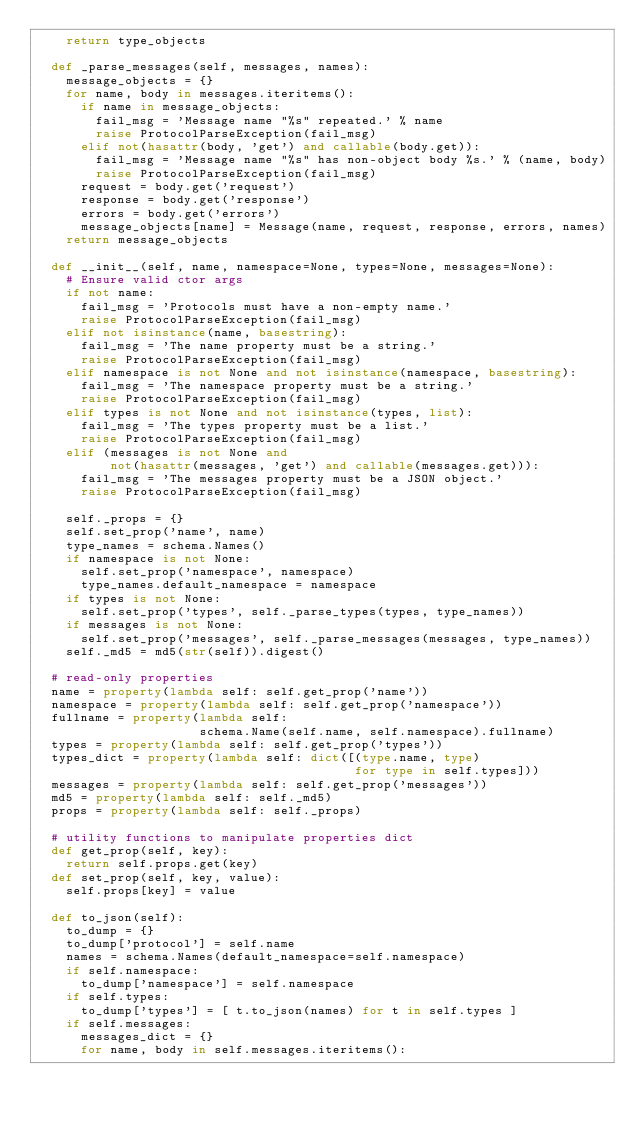Convert code to text. <code><loc_0><loc_0><loc_500><loc_500><_Python_>    return type_objects

  def _parse_messages(self, messages, names):
    message_objects = {}
    for name, body in messages.iteritems():
      if name in message_objects:
        fail_msg = 'Message name "%s" repeated.' % name
        raise ProtocolParseException(fail_msg)
      elif not(hasattr(body, 'get') and callable(body.get)):
        fail_msg = 'Message name "%s" has non-object body %s.' % (name, body)
        raise ProtocolParseException(fail_msg)
      request = body.get('request')
      response = body.get('response')
      errors = body.get('errors')
      message_objects[name] = Message(name, request, response, errors, names)
    return message_objects

  def __init__(self, name, namespace=None, types=None, messages=None):
    # Ensure valid ctor args
    if not name:
      fail_msg = 'Protocols must have a non-empty name.'
      raise ProtocolParseException(fail_msg)
    elif not isinstance(name, basestring):
      fail_msg = 'The name property must be a string.'
      raise ProtocolParseException(fail_msg)
    elif namespace is not None and not isinstance(namespace, basestring):
      fail_msg = 'The namespace property must be a string.'
      raise ProtocolParseException(fail_msg)
    elif types is not None and not isinstance(types, list):
      fail_msg = 'The types property must be a list.'
      raise ProtocolParseException(fail_msg)
    elif (messages is not None and 
          not(hasattr(messages, 'get') and callable(messages.get))):
      fail_msg = 'The messages property must be a JSON object.'
      raise ProtocolParseException(fail_msg)

    self._props = {}
    self.set_prop('name', name)
    type_names = schema.Names()
    if namespace is not None: 
      self.set_prop('namespace', namespace)
      type_names.default_namespace = namespace
    if types is not None:
      self.set_prop('types', self._parse_types(types, type_names))
    if messages is not None:
      self.set_prop('messages', self._parse_messages(messages, type_names))
    self._md5 = md5(str(self)).digest()

  # read-only properties
  name = property(lambda self: self.get_prop('name'))
  namespace = property(lambda self: self.get_prop('namespace'))
  fullname = property(lambda self: 
                      schema.Name(self.name, self.namespace).fullname)
  types = property(lambda self: self.get_prop('types'))
  types_dict = property(lambda self: dict([(type.name, type)
                                           for type in self.types]))
  messages = property(lambda self: self.get_prop('messages'))
  md5 = property(lambda self: self._md5)
  props = property(lambda self: self._props)

  # utility functions to manipulate properties dict
  def get_prop(self, key):
    return self.props.get(key)
  def set_prop(self, key, value):
    self.props[key] = value  

  def to_json(self):
    to_dump = {}
    to_dump['protocol'] = self.name
    names = schema.Names(default_namespace=self.namespace)
    if self.namespace: 
      to_dump['namespace'] = self.namespace
    if self.types:
      to_dump['types'] = [ t.to_json(names) for t in self.types ]
    if self.messages:
      messages_dict = {}
      for name, body in self.messages.iteritems():</code> 